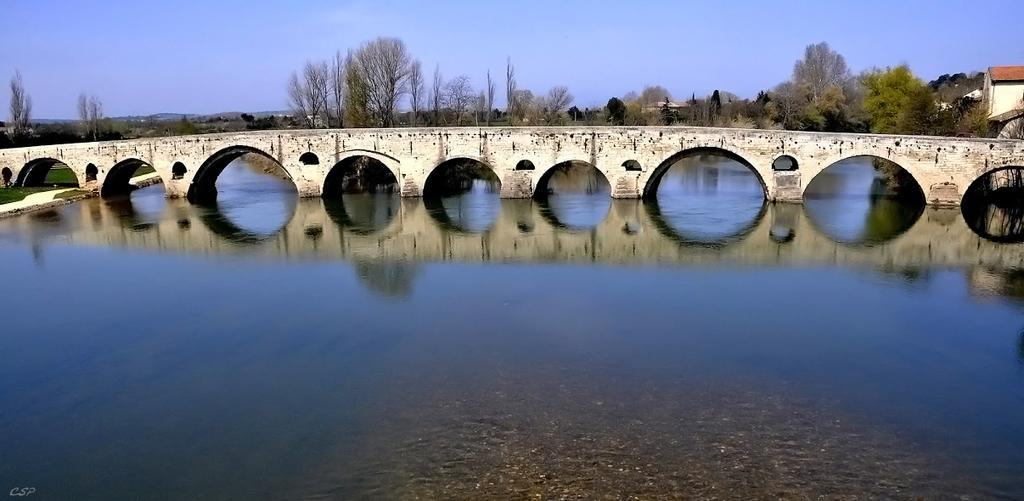What is the main element present in the image? There is water in the image. What type of vegetation can be seen in the image? There is grass in the image. What structure is present in the image? There is a bridge in the image. What can be seen in the background of the image? There are trees, houses, and the sky visible in the background of the image. Can you see any dinosaurs walking through the water in the image? No, there are no dinosaurs present in the image. What type of writing instrument is being used by the trees in the background? Trees do not use writing instruments; there are no quills or any other writing instruments present in the image. 